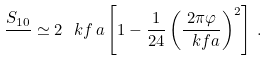<formula> <loc_0><loc_0><loc_500><loc_500>\frac { S _ { 1 0 } } { } \simeq 2 \, \ k f \, a \left [ 1 - \frac { 1 } { 2 4 } \left ( \frac { 2 \pi \varphi } { \ k f a } \right ) ^ { 2 } \right ] \, .</formula> 